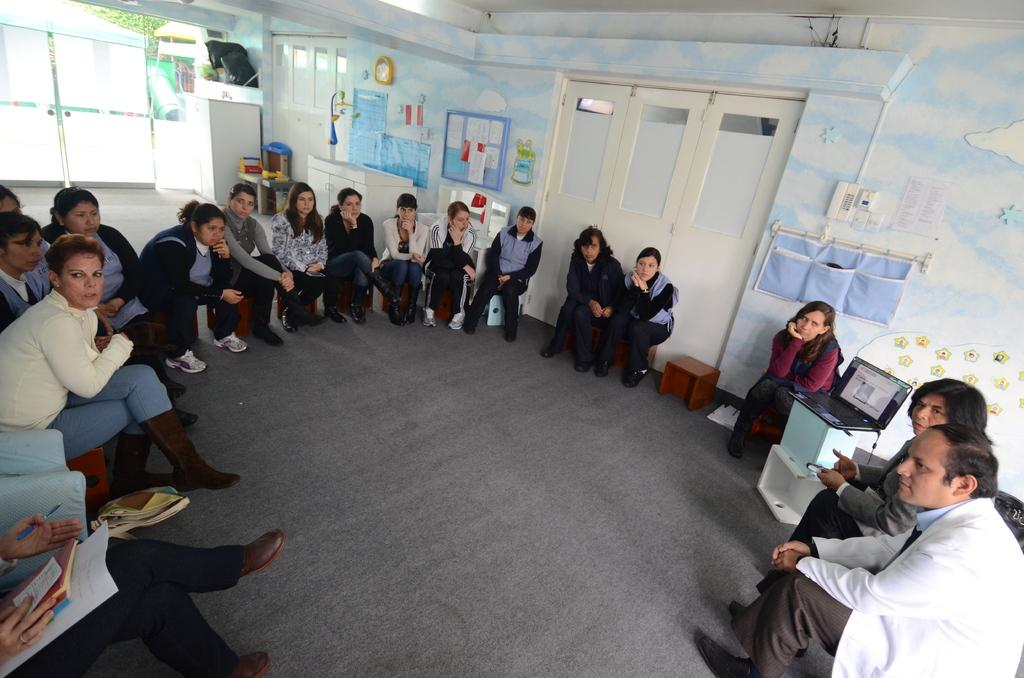What are the people in the image doing? The people in the image are sitting on chairs. What can be seen in the background of the image? There are walls, doors, posters, and clothes visible in the background. Can you describe the walls in the background? The walls in the background have doors and posters on them. What direction is the rod pointing in the image? There is no rod present in the image. What is the aftermath of the event depicted in the image? There is no event depicted in the image, as it shows people sitting on chairs with a background of walls, doors, posters, and clothes. 